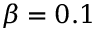Convert formula to latex. <formula><loc_0><loc_0><loc_500><loc_500>\beta = 0 . 1</formula> 